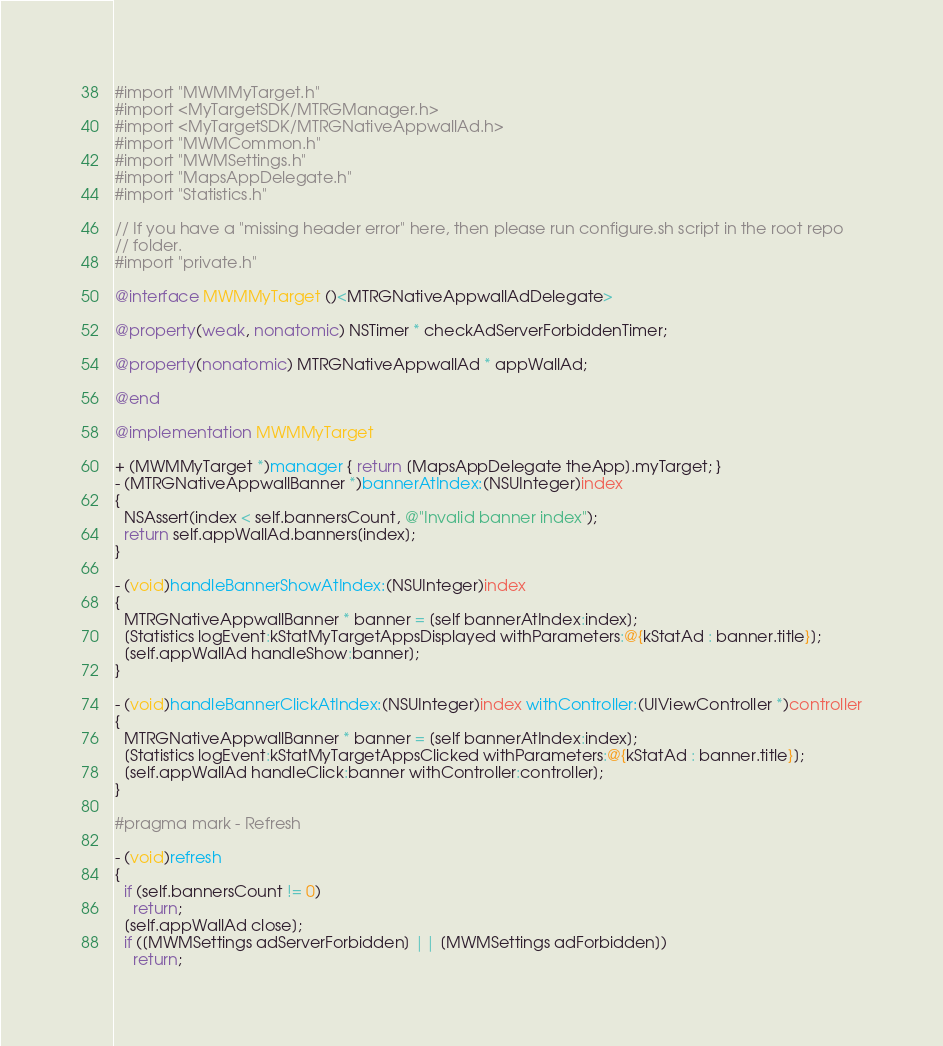<code> <loc_0><loc_0><loc_500><loc_500><_ObjectiveC_>#import "MWMMyTarget.h"
#import <MyTargetSDK/MTRGManager.h>
#import <MyTargetSDK/MTRGNativeAppwallAd.h>
#import "MWMCommon.h"
#import "MWMSettings.h"
#import "MapsAppDelegate.h"
#import "Statistics.h"

// If you have a "missing header error" here, then please run configure.sh script in the root repo
// folder.
#import "private.h"

@interface MWMMyTarget ()<MTRGNativeAppwallAdDelegate>

@property(weak, nonatomic) NSTimer * checkAdServerForbiddenTimer;

@property(nonatomic) MTRGNativeAppwallAd * appWallAd;

@end

@implementation MWMMyTarget

+ (MWMMyTarget *)manager { return [MapsAppDelegate theApp].myTarget; }
- (MTRGNativeAppwallBanner *)bannerAtIndex:(NSUInteger)index
{
  NSAssert(index < self.bannersCount, @"Invalid banner index");
  return self.appWallAd.banners[index];
}

- (void)handleBannerShowAtIndex:(NSUInteger)index
{
  MTRGNativeAppwallBanner * banner = [self bannerAtIndex:index];
  [Statistics logEvent:kStatMyTargetAppsDisplayed withParameters:@{kStatAd : banner.title}];
  [self.appWallAd handleShow:banner];
}

- (void)handleBannerClickAtIndex:(NSUInteger)index withController:(UIViewController *)controller
{
  MTRGNativeAppwallBanner * banner = [self bannerAtIndex:index];
  [Statistics logEvent:kStatMyTargetAppsClicked withParameters:@{kStatAd : banner.title}];
  [self.appWallAd handleClick:banner withController:controller];
}

#pragma mark - Refresh

- (void)refresh
{
  if (self.bannersCount != 0)
    return;
  [self.appWallAd close];
  if ([MWMSettings adServerForbidden] || [MWMSettings adForbidden])
    return;</code> 